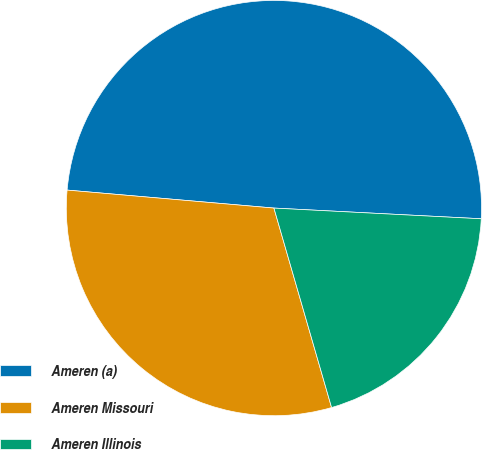Convert chart to OTSL. <chart><loc_0><loc_0><loc_500><loc_500><pie_chart><fcel>Ameren (a)<fcel>Ameren Missouri<fcel>Ameren Illinois<nl><fcel>49.44%<fcel>30.86%<fcel>19.7%<nl></chart> 